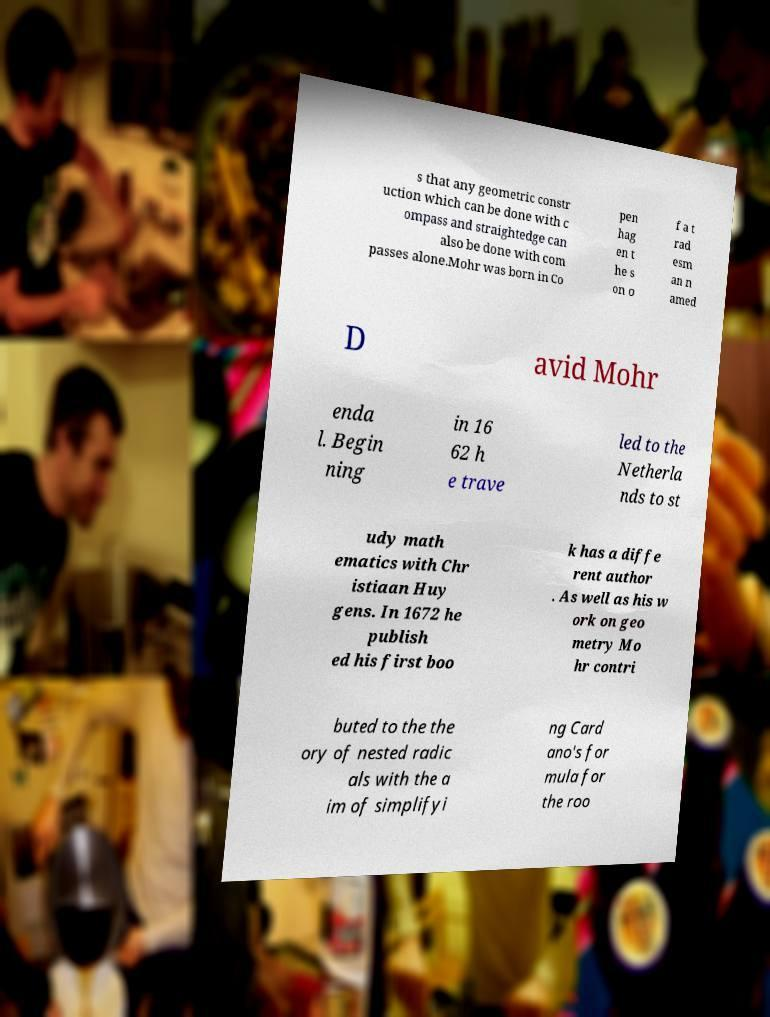Please identify and transcribe the text found in this image. s that any geometric constr uction which can be done with c ompass and straightedge can also be done with com passes alone.Mohr was born in Co pen hag en t he s on o f a t rad esm an n amed D avid Mohr enda l. Begin ning in 16 62 h e trave led to the Netherla nds to st udy math ematics with Chr istiaan Huy gens. In 1672 he publish ed his first boo k has a diffe rent author . As well as his w ork on geo metry Mo hr contri buted to the the ory of nested radic als with the a im of simplifyi ng Card ano's for mula for the roo 